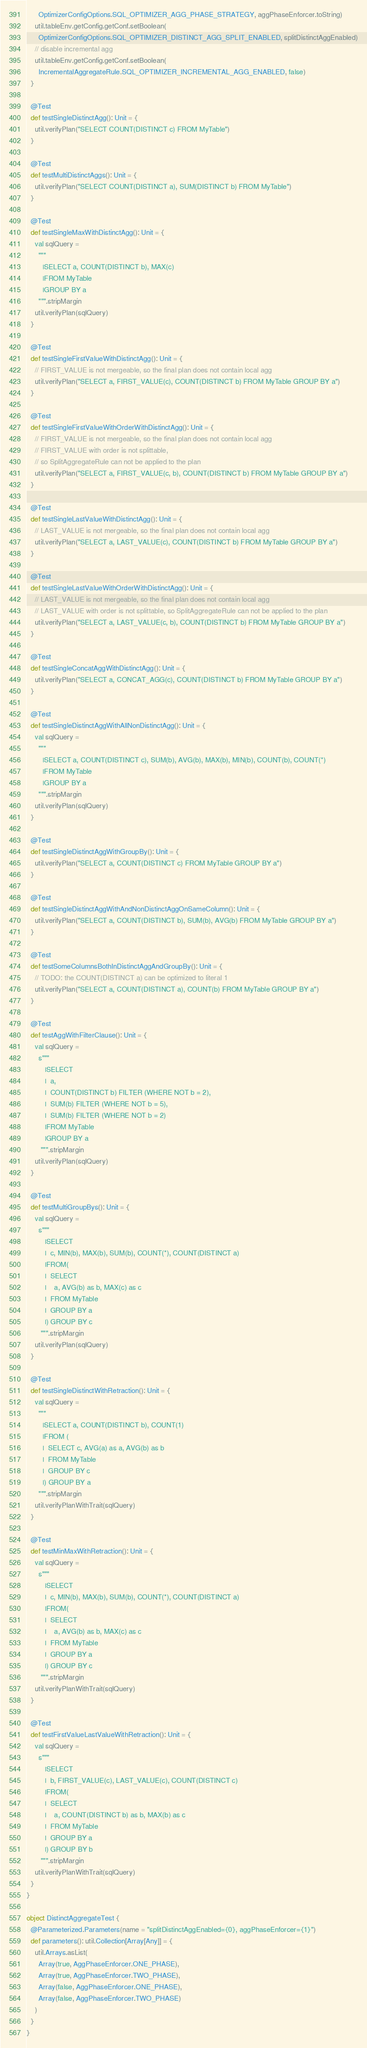Convert code to text. <code><loc_0><loc_0><loc_500><loc_500><_Scala_>      OptimizerConfigOptions.SQL_OPTIMIZER_AGG_PHASE_STRATEGY, aggPhaseEnforcer.toString)
    util.tableEnv.getConfig.getConf.setBoolean(
      OptimizerConfigOptions.SQL_OPTIMIZER_DISTINCT_AGG_SPLIT_ENABLED, splitDistinctAggEnabled)
    // disable incremental agg
    util.tableEnv.getConfig.getConf.setBoolean(
      IncrementalAggregateRule.SQL_OPTIMIZER_INCREMENTAL_AGG_ENABLED, false)
  }

  @Test
  def testSingleDistinctAgg(): Unit = {
    util.verifyPlan("SELECT COUNT(DISTINCT c) FROM MyTable")
  }

  @Test
  def testMultiDistinctAggs(): Unit = {
    util.verifyPlan("SELECT COUNT(DISTINCT a), SUM(DISTINCT b) FROM MyTable")
  }

  @Test
  def testSingleMaxWithDistinctAgg(): Unit = {
    val sqlQuery =
      """
        |SELECT a, COUNT(DISTINCT b), MAX(c)
        |FROM MyTable
        |GROUP BY a
      """.stripMargin
    util.verifyPlan(sqlQuery)
  }

  @Test
  def testSingleFirstValueWithDistinctAgg(): Unit = {
    // FIRST_VALUE is not mergeable, so the final plan does not contain local agg
    util.verifyPlan("SELECT a, FIRST_VALUE(c), COUNT(DISTINCT b) FROM MyTable GROUP BY a")
  }

  @Test
  def testSingleFirstValueWithOrderWithDistinctAgg(): Unit = {
    // FIRST_VALUE is not mergeable, so the final plan does not contain local agg
    // FIRST_VALUE with order is not splittable,
    // so SplitAggregateRule can not be applied to the plan
    util.verifyPlan("SELECT a, FIRST_VALUE(c, b), COUNT(DISTINCT b) FROM MyTable GROUP BY a")
  }

  @Test
  def testSingleLastValueWithDistinctAgg(): Unit = {
    // LAST_VALUE is not mergeable, so the final plan does not contain local agg
    util.verifyPlan("SELECT a, LAST_VALUE(c), COUNT(DISTINCT b) FROM MyTable GROUP BY a")
  }

  @Test
  def testSingleLastValueWithOrderWithDistinctAgg(): Unit = {
    // LAST_VALUE is not mergeable, so the final plan does not contain local agg
    // LAST_VALUE with order is not splittable, so SplitAggregateRule can not be applied to the plan
    util.verifyPlan("SELECT a, LAST_VALUE(c, b), COUNT(DISTINCT b) FROM MyTable GROUP BY a")
  }

  @Test
  def testSingleConcatAggWithDistinctAgg(): Unit = {
    util.verifyPlan("SELECT a, CONCAT_AGG(c), COUNT(DISTINCT b) FROM MyTable GROUP BY a")
  }

  @Test
  def testSingleDistinctAggWithAllNonDistinctAgg(): Unit = {
    val sqlQuery =
      """
        |SELECT a, COUNT(DISTINCT c), SUM(b), AVG(b), MAX(b), MIN(b), COUNT(b), COUNT(*)
        |FROM MyTable
        |GROUP BY a
      """.stripMargin
    util.verifyPlan(sqlQuery)
  }

  @Test
  def testSingleDistinctAggWithGroupBy(): Unit = {
    util.verifyPlan("SELECT a, COUNT(DISTINCT c) FROM MyTable GROUP BY a")
  }

  @Test
  def testSingleDistinctAggWithAndNonDistinctAggOnSameColumn(): Unit = {
    util.verifyPlan("SELECT a, COUNT(DISTINCT b), SUM(b), AVG(b) FROM MyTable GROUP BY a")
  }

  @Test
  def testSomeColumnsBothInDistinctAggAndGroupBy(): Unit = {
    // TODO: the COUNT(DISTINCT a) can be optimized to literal 1
    util.verifyPlan("SELECT a, COUNT(DISTINCT a), COUNT(b) FROM MyTable GROUP BY a")
  }

  @Test
  def testAggWithFilterClause(): Unit = {
    val sqlQuery =
      s"""
         |SELECT
         |  a,
         |  COUNT(DISTINCT b) FILTER (WHERE NOT b = 2),
         |  SUM(b) FILTER (WHERE NOT b = 5),
         |  SUM(b) FILTER (WHERE NOT b = 2)
         |FROM MyTable
         |GROUP BY a
       """.stripMargin
    util.verifyPlan(sqlQuery)
  }

  @Test
  def testMultiGroupBys(): Unit = {
    val sqlQuery =
      s"""
         |SELECT
         |  c, MIN(b), MAX(b), SUM(b), COUNT(*), COUNT(DISTINCT a)
         |FROM(
         |  SELECT
         |    a, AVG(b) as b, MAX(c) as c
         |  FROM MyTable
         |  GROUP BY a
         |) GROUP BY c
       """.stripMargin
    util.verifyPlan(sqlQuery)
  }

  @Test
  def testSingleDistinctWithRetraction(): Unit = {
    val sqlQuery =
      """
        |SELECT a, COUNT(DISTINCT b), COUNT(1)
        |FROM (
        |  SELECT c, AVG(a) as a, AVG(b) as b
        |  FROM MyTable
        |  GROUP BY c
        |) GROUP BY a
      """.stripMargin
    util.verifyPlanWithTrait(sqlQuery)
  }

  @Test
  def testMinMaxWithRetraction(): Unit = {
    val sqlQuery =
      s"""
         |SELECT
         |  c, MIN(b), MAX(b), SUM(b), COUNT(*), COUNT(DISTINCT a)
         |FROM(
         |  SELECT
         |    a, AVG(b) as b, MAX(c) as c
         |  FROM MyTable
         |  GROUP BY a
         |) GROUP BY c
       """.stripMargin
    util.verifyPlanWithTrait(sqlQuery)
  }

  @Test
  def testFirstValueLastValueWithRetraction(): Unit = {
    val sqlQuery =
      s"""
         |SELECT
         |  b, FIRST_VALUE(c), LAST_VALUE(c), COUNT(DISTINCT c)
         |FROM(
         |  SELECT
         |    a, COUNT(DISTINCT b) as b, MAX(b) as c
         |  FROM MyTable
         |  GROUP BY a
         |) GROUP BY b
       """.stripMargin
    util.verifyPlanWithTrait(sqlQuery)
  }
}

object DistinctAggregateTest {
  @Parameterized.Parameters(name = "splitDistinctAggEnabled={0}, aggPhaseEnforcer={1}")
  def parameters(): util.Collection[Array[Any]] = {
    util.Arrays.asList(
      Array(true, AggPhaseEnforcer.ONE_PHASE),
      Array(true, AggPhaseEnforcer.TWO_PHASE),
      Array(false, AggPhaseEnforcer.ONE_PHASE),
      Array(false, AggPhaseEnforcer.TWO_PHASE)
    )
  }
}
</code> 